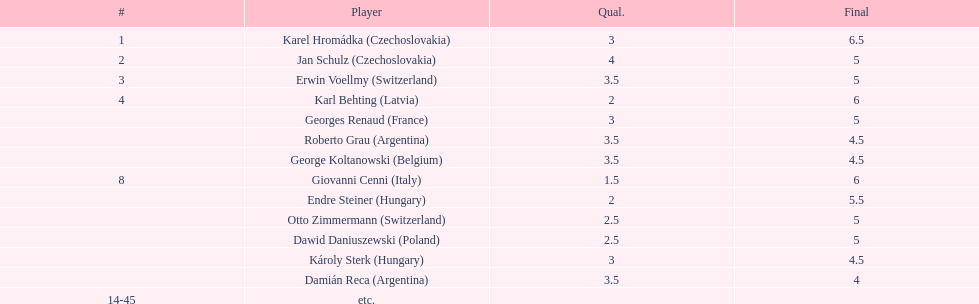Parse the full table. {'header': ['#', 'Player', 'Qual.', 'Final'], 'rows': [['1', 'Karel Hromádka\xa0(Czechoslovakia)', '3', '6.5'], ['2', 'Jan Schulz\xa0(Czechoslovakia)', '4', '5'], ['3', 'Erwin Voellmy\xa0(Switzerland)', '3.5', '5'], ['4', 'Karl Behting\xa0(Latvia)', '2', '6'], ['', 'Georges Renaud\xa0(France)', '3', '5'], ['', 'Roberto Grau\xa0(Argentina)', '3.5', '4.5'], ['', 'George Koltanowski\xa0(Belgium)', '3.5', '4.5'], ['8', 'Giovanni Cenni\xa0(Italy)', '1.5', '6'], ['', 'Endre Steiner\xa0(Hungary)', '2', '5.5'], ['', 'Otto Zimmermann\xa0(Switzerland)', '2.5', '5'], ['', 'Dawid Daniuszewski\xa0(Poland)', '2.5', '5'], ['', 'Károly Sterk\xa0(Hungary)', '3', '4.5'], ['', 'Damián Reca\xa0(Argentina)', '3.5', '4'], ['14-45', 'etc.', '', '']]} Jan schulz is ranked immediately below which player? Karel Hromádka. 